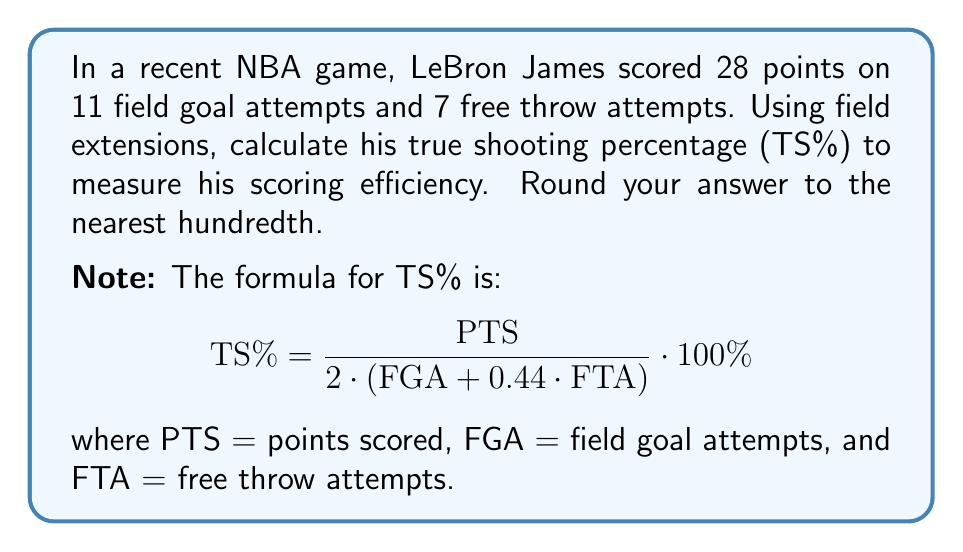Can you solve this math problem? Let's approach this step-by-step using field extensions:

1) First, we need to set up our base field $F$ as the rational numbers $\mathbb{Q}$.

2) We'll create a field extension $F(x)$ where $x$ represents the TS%.

3) Using the given formula, we can set up the equation:

   $$x = \frac{28}{2 \cdot (11 + 0.44 \cdot 7)} \cdot 100\%$$

4) Let's simplify the denominator:
   $$11 + 0.44 \cdot 7 = 11 + 3.08 = 14.08$$

5) Now our equation looks like:
   $$x = \frac{28}{2 \cdot 14.08} \cdot 100\%$$

6) Simplify further:
   $$x = \frac{28}{28.16} \cdot 100\%$$

7) Divide:
   $$x = 0.9943 \cdot 100\% = 99.43\%$$

8) Rounding to the nearest hundredth:
   $$x \approx 99.43\%$$

Thus, in the field extension $F(x)$, we've found that $x \approx 99.43\%$.
Answer: 99.43% 